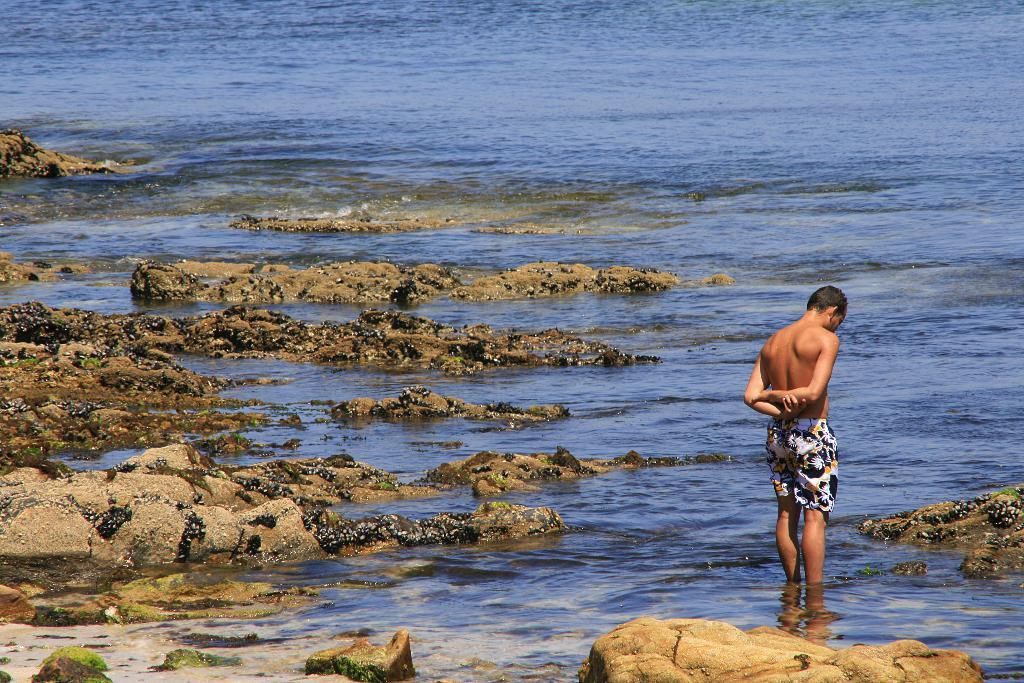What is the main subject of the image? There is a man standing in the image. What can be seen at the bottom of the image? Water, soil, and rocks are visible at the bottom of the image. How many chickens are swimming in the water at the bottom of the image? There are no chickens present in the image; only water, soil, and rocks can be seen at the bottom. 